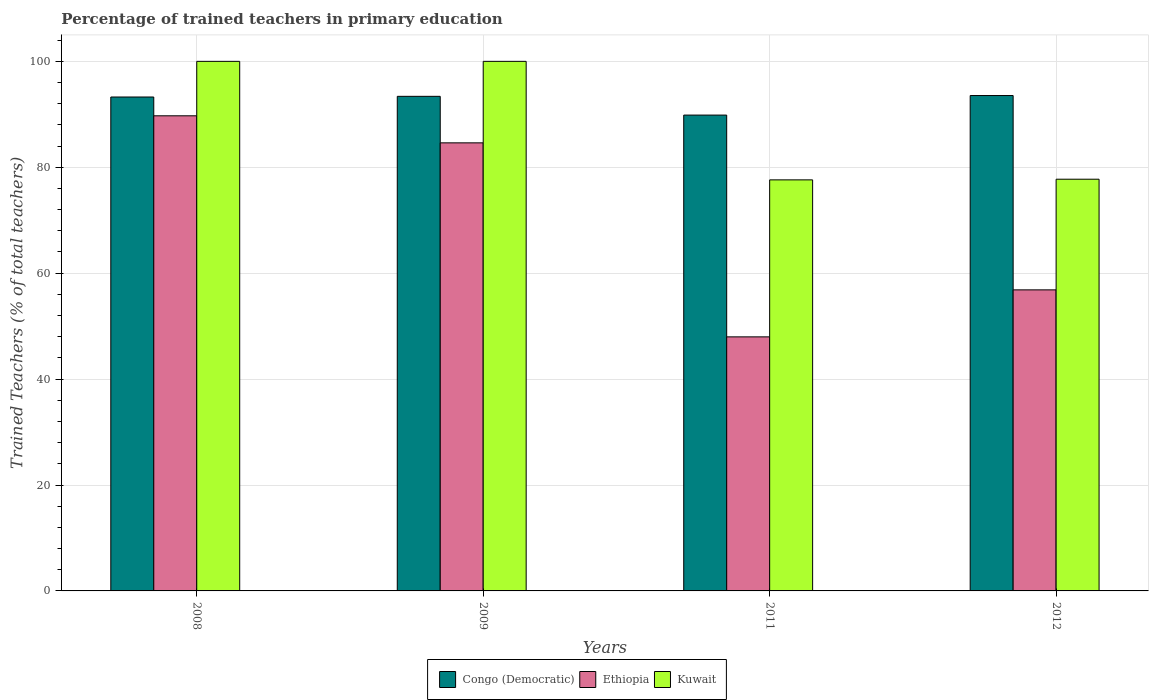How many different coloured bars are there?
Provide a short and direct response. 3. Are the number of bars per tick equal to the number of legend labels?
Your answer should be very brief. Yes. Are the number of bars on each tick of the X-axis equal?
Keep it short and to the point. Yes. How many bars are there on the 4th tick from the left?
Offer a terse response. 3. How many bars are there on the 3rd tick from the right?
Offer a very short reply. 3. What is the label of the 1st group of bars from the left?
Offer a terse response. 2008. In how many cases, is the number of bars for a given year not equal to the number of legend labels?
Provide a succinct answer. 0. What is the percentage of trained teachers in Congo (Democratic) in 2011?
Your answer should be very brief. 89.85. Across all years, what is the maximum percentage of trained teachers in Congo (Democratic)?
Provide a short and direct response. 93.55. Across all years, what is the minimum percentage of trained teachers in Kuwait?
Offer a terse response. 77.62. In which year was the percentage of trained teachers in Ethiopia maximum?
Ensure brevity in your answer.  2008. In which year was the percentage of trained teachers in Ethiopia minimum?
Your answer should be compact. 2011. What is the total percentage of trained teachers in Congo (Democratic) in the graph?
Offer a very short reply. 370.06. What is the difference between the percentage of trained teachers in Ethiopia in 2009 and that in 2011?
Your answer should be compact. 36.64. What is the difference between the percentage of trained teachers in Kuwait in 2011 and the percentage of trained teachers in Congo (Democratic) in 2009?
Ensure brevity in your answer.  -15.77. What is the average percentage of trained teachers in Kuwait per year?
Offer a terse response. 88.84. In the year 2012, what is the difference between the percentage of trained teachers in Kuwait and percentage of trained teachers in Ethiopia?
Provide a succinct answer. 20.9. What is the ratio of the percentage of trained teachers in Congo (Democratic) in 2008 to that in 2012?
Provide a succinct answer. 1. What is the difference between the highest and the second highest percentage of trained teachers in Kuwait?
Offer a very short reply. 0. What is the difference between the highest and the lowest percentage of trained teachers in Ethiopia?
Your answer should be compact. 41.74. Is the sum of the percentage of trained teachers in Congo (Democratic) in 2009 and 2012 greater than the maximum percentage of trained teachers in Kuwait across all years?
Provide a short and direct response. Yes. What does the 2nd bar from the left in 2009 represents?
Provide a short and direct response. Ethiopia. What does the 2nd bar from the right in 2009 represents?
Keep it short and to the point. Ethiopia. Is it the case that in every year, the sum of the percentage of trained teachers in Kuwait and percentage of trained teachers in Ethiopia is greater than the percentage of trained teachers in Congo (Democratic)?
Give a very brief answer. Yes. How many bars are there?
Ensure brevity in your answer.  12. How many legend labels are there?
Ensure brevity in your answer.  3. What is the title of the graph?
Ensure brevity in your answer.  Percentage of trained teachers in primary education. Does "Arab World" appear as one of the legend labels in the graph?
Give a very brief answer. No. What is the label or title of the X-axis?
Your response must be concise. Years. What is the label or title of the Y-axis?
Provide a succinct answer. Trained Teachers (% of total teachers). What is the Trained Teachers (% of total teachers) in Congo (Democratic) in 2008?
Ensure brevity in your answer.  93.27. What is the Trained Teachers (% of total teachers) in Ethiopia in 2008?
Keep it short and to the point. 89.72. What is the Trained Teachers (% of total teachers) of Kuwait in 2008?
Make the answer very short. 100. What is the Trained Teachers (% of total teachers) in Congo (Democratic) in 2009?
Give a very brief answer. 93.39. What is the Trained Teachers (% of total teachers) in Ethiopia in 2009?
Your answer should be compact. 84.61. What is the Trained Teachers (% of total teachers) of Kuwait in 2009?
Provide a short and direct response. 100. What is the Trained Teachers (% of total teachers) of Congo (Democratic) in 2011?
Offer a terse response. 89.85. What is the Trained Teachers (% of total teachers) of Ethiopia in 2011?
Your answer should be very brief. 47.97. What is the Trained Teachers (% of total teachers) in Kuwait in 2011?
Your answer should be compact. 77.62. What is the Trained Teachers (% of total teachers) of Congo (Democratic) in 2012?
Offer a very short reply. 93.55. What is the Trained Teachers (% of total teachers) in Ethiopia in 2012?
Your answer should be compact. 56.85. What is the Trained Teachers (% of total teachers) of Kuwait in 2012?
Give a very brief answer. 77.74. Across all years, what is the maximum Trained Teachers (% of total teachers) in Congo (Democratic)?
Your answer should be compact. 93.55. Across all years, what is the maximum Trained Teachers (% of total teachers) in Ethiopia?
Offer a very short reply. 89.72. Across all years, what is the maximum Trained Teachers (% of total teachers) of Kuwait?
Your answer should be very brief. 100. Across all years, what is the minimum Trained Teachers (% of total teachers) in Congo (Democratic)?
Give a very brief answer. 89.85. Across all years, what is the minimum Trained Teachers (% of total teachers) in Ethiopia?
Your response must be concise. 47.97. Across all years, what is the minimum Trained Teachers (% of total teachers) of Kuwait?
Provide a short and direct response. 77.62. What is the total Trained Teachers (% of total teachers) of Congo (Democratic) in the graph?
Give a very brief answer. 370.06. What is the total Trained Teachers (% of total teachers) of Ethiopia in the graph?
Ensure brevity in your answer.  279.15. What is the total Trained Teachers (% of total teachers) of Kuwait in the graph?
Your answer should be compact. 355.36. What is the difference between the Trained Teachers (% of total teachers) of Congo (Democratic) in 2008 and that in 2009?
Offer a very short reply. -0.13. What is the difference between the Trained Teachers (% of total teachers) in Ethiopia in 2008 and that in 2009?
Your answer should be very brief. 5.11. What is the difference between the Trained Teachers (% of total teachers) of Kuwait in 2008 and that in 2009?
Give a very brief answer. 0. What is the difference between the Trained Teachers (% of total teachers) in Congo (Democratic) in 2008 and that in 2011?
Your answer should be very brief. 3.41. What is the difference between the Trained Teachers (% of total teachers) in Ethiopia in 2008 and that in 2011?
Provide a succinct answer. 41.74. What is the difference between the Trained Teachers (% of total teachers) in Kuwait in 2008 and that in 2011?
Provide a succinct answer. 22.38. What is the difference between the Trained Teachers (% of total teachers) of Congo (Democratic) in 2008 and that in 2012?
Offer a very short reply. -0.28. What is the difference between the Trained Teachers (% of total teachers) in Ethiopia in 2008 and that in 2012?
Provide a short and direct response. 32.87. What is the difference between the Trained Teachers (% of total teachers) of Kuwait in 2008 and that in 2012?
Offer a terse response. 22.26. What is the difference between the Trained Teachers (% of total teachers) of Congo (Democratic) in 2009 and that in 2011?
Offer a very short reply. 3.54. What is the difference between the Trained Teachers (% of total teachers) in Ethiopia in 2009 and that in 2011?
Give a very brief answer. 36.64. What is the difference between the Trained Teachers (% of total teachers) of Kuwait in 2009 and that in 2011?
Your response must be concise. 22.38. What is the difference between the Trained Teachers (% of total teachers) in Congo (Democratic) in 2009 and that in 2012?
Provide a succinct answer. -0.15. What is the difference between the Trained Teachers (% of total teachers) of Ethiopia in 2009 and that in 2012?
Provide a succinct answer. 27.76. What is the difference between the Trained Teachers (% of total teachers) of Kuwait in 2009 and that in 2012?
Make the answer very short. 22.26. What is the difference between the Trained Teachers (% of total teachers) in Congo (Democratic) in 2011 and that in 2012?
Your response must be concise. -3.69. What is the difference between the Trained Teachers (% of total teachers) of Ethiopia in 2011 and that in 2012?
Make the answer very short. -8.87. What is the difference between the Trained Teachers (% of total teachers) of Kuwait in 2011 and that in 2012?
Provide a succinct answer. -0.12. What is the difference between the Trained Teachers (% of total teachers) in Congo (Democratic) in 2008 and the Trained Teachers (% of total teachers) in Ethiopia in 2009?
Offer a very short reply. 8.66. What is the difference between the Trained Teachers (% of total teachers) of Congo (Democratic) in 2008 and the Trained Teachers (% of total teachers) of Kuwait in 2009?
Your answer should be compact. -6.73. What is the difference between the Trained Teachers (% of total teachers) of Ethiopia in 2008 and the Trained Teachers (% of total teachers) of Kuwait in 2009?
Make the answer very short. -10.28. What is the difference between the Trained Teachers (% of total teachers) in Congo (Democratic) in 2008 and the Trained Teachers (% of total teachers) in Ethiopia in 2011?
Keep it short and to the point. 45.29. What is the difference between the Trained Teachers (% of total teachers) in Congo (Democratic) in 2008 and the Trained Teachers (% of total teachers) in Kuwait in 2011?
Provide a short and direct response. 15.65. What is the difference between the Trained Teachers (% of total teachers) of Ethiopia in 2008 and the Trained Teachers (% of total teachers) of Kuwait in 2011?
Give a very brief answer. 12.1. What is the difference between the Trained Teachers (% of total teachers) of Congo (Democratic) in 2008 and the Trained Teachers (% of total teachers) of Ethiopia in 2012?
Provide a short and direct response. 36.42. What is the difference between the Trained Teachers (% of total teachers) in Congo (Democratic) in 2008 and the Trained Teachers (% of total teachers) in Kuwait in 2012?
Your answer should be very brief. 15.52. What is the difference between the Trained Teachers (% of total teachers) of Ethiopia in 2008 and the Trained Teachers (% of total teachers) of Kuwait in 2012?
Your answer should be compact. 11.97. What is the difference between the Trained Teachers (% of total teachers) in Congo (Democratic) in 2009 and the Trained Teachers (% of total teachers) in Ethiopia in 2011?
Ensure brevity in your answer.  45.42. What is the difference between the Trained Teachers (% of total teachers) in Congo (Democratic) in 2009 and the Trained Teachers (% of total teachers) in Kuwait in 2011?
Offer a very short reply. 15.77. What is the difference between the Trained Teachers (% of total teachers) in Ethiopia in 2009 and the Trained Teachers (% of total teachers) in Kuwait in 2011?
Offer a very short reply. 6.99. What is the difference between the Trained Teachers (% of total teachers) in Congo (Democratic) in 2009 and the Trained Teachers (% of total teachers) in Ethiopia in 2012?
Make the answer very short. 36.54. What is the difference between the Trained Teachers (% of total teachers) in Congo (Democratic) in 2009 and the Trained Teachers (% of total teachers) in Kuwait in 2012?
Your answer should be compact. 15.65. What is the difference between the Trained Teachers (% of total teachers) in Ethiopia in 2009 and the Trained Teachers (% of total teachers) in Kuwait in 2012?
Your answer should be very brief. 6.87. What is the difference between the Trained Teachers (% of total teachers) of Congo (Democratic) in 2011 and the Trained Teachers (% of total teachers) of Ethiopia in 2012?
Your response must be concise. 33. What is the difference between the Trained Teachers (% of total teachers) of Congo (Democratic) in 2011 and the Trained Teachers (% of total teachers) of Kuwait in 2012?
Provide a short and direct response. 12.11. What is the difference between the Trained Teachers (% of total teachers) in Ethiopia in 2011 and the Trained Teachers (% of total teachers) in Kuwait in 2012?
Make the answer very short. -29.77. What is the average Trained Teachers (% of total teachers) of Congo (Democratic) per year?
Ensure brevity in your answer.  92.52. What is the average Trained Teachers (% of total teachers) in Ethiopia per year?
Your answer should be compact. 69.79. What is the average Trained Teachers (% of total teachers) in Kuwait per year?
Keep it short and to the point. 88.84. In the year 2008, what is the difference between the Trained Teachers (% of total teachers) in Congo (Democratic) and Trained Teachers (% of total teachers) in Ethiopia?
Your answer should be very brief. 3.55. In the year 2008, what is the difference between the Trained Teachers (% of total teachers) in Congo (Democratic) and Trained Teachers (% of total teachers) in Kuwait?
Your response must be concise. -6.73. In the year 2008, what is the difference between the Trained Teachers (% of total teachers) of Ethiopia and Trained Teachers (% of total teachers) of Kuwait?
Your response must be concise. -10.28. In the year 2009, what is the difference between the Trained Teachers (% of total teachers) in Congo (Democratic) and Trained Teachers (% of total teachers) in Ethiopia?
Give a very brief answer. 8.78. In the year 2009, what is the difference between the Trained Teachers (% of total teachers) in Congo (Democratic) and Trained Teachers (% of total teachers) in Kuwait?
Ensure brevity in your answer.  -6.61. In the year 2009, what is the difference between the Trained Teachers (% of total teachers) of Ethiopia and Trained Teachers (% of total teachers) of Kuwait?
Your answer should be very brief. -15.39. In the year 2011, what is the difference between the Trained Teachers (% of total teachers) of Congo (Democratic) and Trained Teachers (% of total teachers) of Ethiopia?
Provide a short and direct response. 41.88. In the year 2011, what is the difference between the Trained Teachers (% of total teachers) of Congo (Democratic) and Trained Teachers (% of total teachers) of Kuwait?
Provide a succinct answer. 12.23. In the year 2011, what is the difference between the Trained Teachers (% of total teachers) in Ethiopia and Trained Teachers (% of total teachers) in Kuwait?
Your answer should be very brief. -29.65. In the year 2012, what is the difference between the Trained Teachers (% of total teachers) in Congo (Democratic) and Trained Teachers (% of total teachers) in Ethiopia?
Offer a terse response. 36.7. In the year 2012, what is the difference between the Trained Teachers (% of total teachers) in Congo (Democratic) and Trained Teachers (% of total teachers) in Kuwait?
Offer a very short reply. 15.8. In the year 2012, what is the difference between the Trained Teachers (% of total teachers) in Ethiopia and Trained Teachers (% of total teachers) in Kuwait?
Give a very brief answer. -20.9. What is the ratio of the Trained Teachers (% of total teachers) in Ethiopia in 2008 to that in 2009?
Your answer should be compact. 1.06. What is the ratio of the Trained Teachers (% of total teachers) in Congo (Democratic) in 2008 to that in 2011?
Provide a succinct answer. 1.04. What is the ratio of the Trained Teachers (% of total teachers) of Ethiopia in 2008 to that in 2011?
Offer a terse response. 1.87. What is the ratio of the Trained Teachers (% of total teachers) of Kuwait in 2008 to that in 2011?
Your response must be concise. 1.29. What is the ratio of the Trained Teachers (% of total teachers) in Ethiopia in 2008 to that in 2012?
Keep it short and to the point. 1.58. What is the ratio of the Trained Teachers (% of total teachers) of Kuwait in 2008 to that in 2012?
Keep it short and to the point. 1.29. What is the ratio of the Trained Teachers (% of total teachers) in Congo (Democratic) in 2009 to that in 2011?
Ensure brevity in your answer.  1.04. What is the ratio of the Trained Teachers (% of total teachers) in Ethiopia in 2009 to that in 2011?
Provide a succinct answer. 1.76. What is the ratio of the Trained Teachers (% of total teachers) in Kuwait in 2009 to that in 2011?
Give a very brief answer. 1.29. What is the ratio of the Trained Teachers (% of total teachers) of Congo (Democratic) in 2009 to that in 2012?
Your answer should be very brief. 1. What is the ratio of the Trained Teachers (% of total teachers) in Ethiopia in 2009 to that in 2012?
Give a very brief answer. 1.49. What is the ratio of the Trained Teachers (% of total teachers) of Kuwait in 2009 to that in 2012?
Make the answer very short. 1.29. What is the ratio of the Trained Teachers (% of total teachers) of Congo (Democratic) in 2011 to that in 2012?
Provide a short and direct response. 0.96. What is the ratio of the Trained Teachers (% of total teachers) of Ethiopia in 2011 to that in 2012?
Your response must be concise. 0.84. What is the difference between the highest and the second highest Trained Teachers (% of total teachers) in Congo (Democratic)?
Provide a succinct answer. 0.15. What is the difference between the highest and the second highest Trained Teachers (% of total teachers) in Ethiopia?
Offer a very short reply. 5.11. What is the difference between the highest and the lowest Trained Teachers (% of total teachers) in Congo (Democratic)?
Keep it short and to the point. 3.69. What is the difference between the highest and the lowest Trained Teachers (% of total teachers) of Ethiopia?
Provide a succinct answer. 41.74. What is the difference between the highest and the lowest Trained Teachers (% of total teachers) of Kuwait?
Provide a succinct answer. 22.38. 